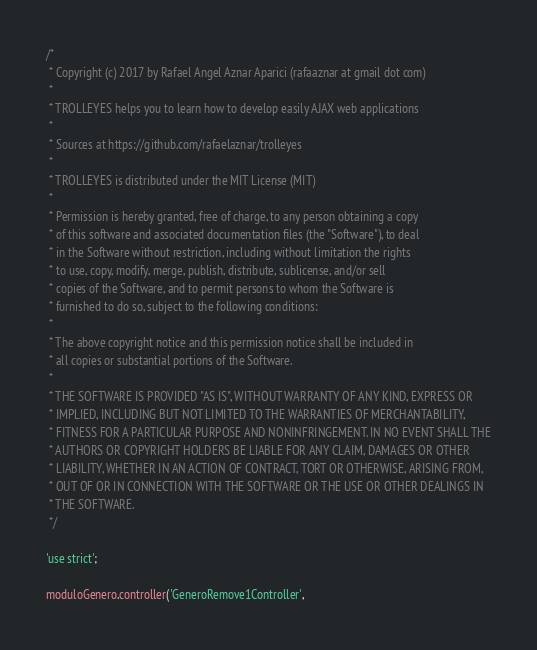Convert code to text. <code><loc_0><loc_0><loc_500><loc_500><_JavaScript_>/*
 * Copyright (c) 2017 by Rafael Angel Aznar Aparici (rafaaznar at gmail dot com)
 *
 * TROLLEYES helps you to learn how to develop easily AJAX web applications
 *
 * Sources at https://github.com/rafaelaznar/trolleyes
 *
 * TROLLEYES is distributed under the MIT License (MIT)
 *
 * Permission is hereby granted, free of charge, to any person obtaining a copy
 * of this software and associated documentation files (the "Software"), to deal
 * in the Software without restriction, including without limitation the rights
 * to use, copy, modify, merge, publish, distribute, sublicense, and/or sell
 * copies of the Software, and to permit persons to whom the Software is
 * furnished to do so, subject to the following conditions:
 *
 * The above copyright notice and this permission notice shall be included in
 * all copies or substantial portions of the Software.
 *
 * THE SOFTWARE IS PROVIDED "AS IS", WITHOUT WARRANTY OF ANY KIND, EXPRESS OR
 * IMPLIED, INCLUDING BUT NOT LIMITED TO THE WARRANTIES OF MERCHANTABILITY,
 * FITNESS FOR A PARTICULAR PURPOSE AND NONINFRINGEMENT. IN NO EVENT SHALL THE
 * AUTHORS OR COPYRIGHT HOLDERS BE LIABLE FOR ANY CLAIM, DAMAGES OR OTHER
 * LIABILITY, WHETHER IN AN ACTION OF CONTRACT, TORT OR OTHERWISE, ARISING FROM,
 * OUT OF OR IN CONNECTION WITH THE SOFTWARE OR THE USE OR OTHER DEALINGS IN
 * THE SOFTWARE.
 */

'use strict';

moduloGenero.controller('GeneroRemove1Controller',</code> 